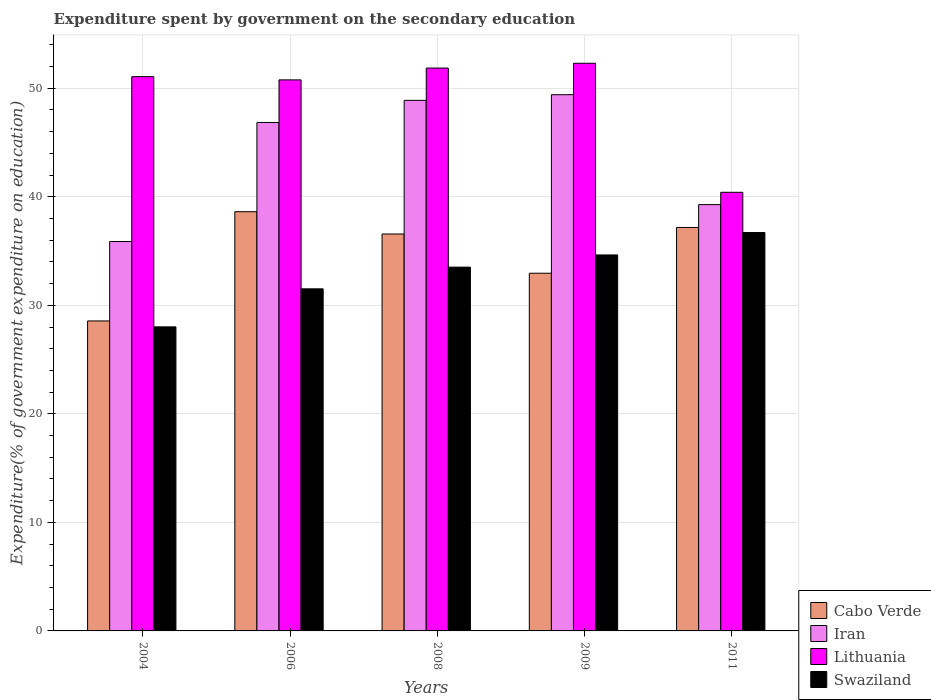How many groups of bars are there?
Give a very brief answer. 5. Are the number of bars per tick equal to the number of legend labels?
Provide a succinct answer. Yes. How many bars are there on the 3rd tick from the left?
Your answer should be compact. 4. What is the expenditure spent by government on the secondary education in Swaziland in 2004?
Provide a short and direct response. 28.02. Across all years, what is the maximum expenditure spent by government on the secondary education in Cabo Verde?
Provide a short and direct response. 38.63. Across all years, what is the minimum expenditure spent by government on the secondary education in Lithuania?
Ensure brevity in your answer.  40.42. In which year was the expenditure spent by government on the secondary education in Swaziland maximum?
Give a very brief answer. 2011. In which year was the expenditure spent by government on the secondary education in Iran minimum?
Offer a very short reply. 2004. What is the total expenditure spent by government on the secondary education in Cabo Verde in the graph?
Offer a very short reply. 173.89. What is the difference between the expenditure spent by government on the secondary education in Lithuania in 2008 and that in 2011?
Offer a terse response. 11.45. What is the difference between the expenditure spent by government on the secondary education in Iran in 2011 and the expenditure spent by government on the secondary education in Cabo Verde in 2009?
Your answer should be compact. 6.32. What is the average expenditure spent by government on the secondary education in Lithuania per year?
Keep it short and to the point. 49.29. In the year 2011, what is the difference between the expenditure spent by government on the secondary education in Swaziland and expenditure spent by government on the secondary education in Iran?
Offer a terse response. -2.57. What is the ratio of the expenditure spent by government on the secondary education in Swaziland in 2006 to that in 2011?
Provide a succinct answer. 0.86. What is the difference between the highest and the second highest expenditure spent by government on the secondary education in Cabo Verde?
Offer a terse response. 1.45. What is the difference between the highest and the lowest expenditure spent by government on the secondary education in Iran?
Your answer should be very brief. 13.53. In how many years, is the expenditure spent by government on the secondary education in Swaziland greater than the average expenditure spent by government on the secondary education in Swaziland taken over all years?
Make the answer very short. 3. Is it the case that in every year, the sum of the expenditure spent by government on the secondary education in Lithuania and expenditure spent by government on the secondary education in Cabo Verde is greater than the sum of expenditure spent by government on the secondary education in Iran and expenditure spent by government on the secondary education in Swaziland?
Give a very brief answer. No. What does the 2nd bar from the left in 2009 represents?
Keep it short and to the point. Iran. What does the 1st bar from the right in 2004 represents?
Provide a short and direct response. Swaziland. Is it the case that in every year, the sum of the expenditure spent by government on the secondary education in Cabo Verde and expenditure spent by government on the secondary education in Lithuania is greater than the expenditure spent by government on the secondary education in Iran?
Offer a very short reply. Yes. Are the values on the major ticks of Y-axis written in scientific E-notation?
Keep it short and to the point. No. Does the graph contain any zero values?
Give a very brief answer. No. Does the graph contain grids?
Your answer should be compact. Yes. Where does the legend appear in the graph?
Offer a terse response. Bottom right. What is the title of the graph?
Give a very brief answer. Expenditure spent by government on the secondary education. What is the label or title of the X-axis?
Provide a succinct answer. Years. What is the label or title of the Y-axis?
Offer a terse response. Expenditure(% of government expenditure on education). What is the Expenditure(% of government expenditure on education) in Cabo Verde in 2004?
Your answer should be compact. 28.56. What is the Expenditure(% of government expenditure on education) of Iran in 2004?
Ensure brevity in your answer.  35.88. What is the Expenditure(% of government expenditure on education) of Lithuania in 2004?
Provide a short and direct response. 51.07. What is the Expenditure(% of government expenditure on education) of Swaziland in 2004?
Provide a succinct answer. 28.02. What is the Expenditure(% of government expenditure on education) of Cabo Verde in 2006?
Offer a very short reply. 38.63. What is the Expenditure(% of government expenditure on education) of Iran in 2006?
Offer a very short reply. 46.85. What is the Expenditure(% of government expenditure on education) in Lithuania in 2006?
Offer a very short reply. 50.77. What is the Expenditure(% of government expenditure on education) in Swaziland in 2006?
Give a very brief answer. 31.52. What is the Expenditure(% of government expenditure on education) of Cabo Verde in 2008?
Provide a succinct answer. 36.57. What is the Expenditure(% of government expenditure on education) in Iran in 2008?
Ensure brevity in your answer.  48.89. What is the Expenditure(% of government expenditure on education) in Lithuania in 2008?
Your response must be concise. 51.86. What is the Expenditure(% of government expenditure on education) in Swaziland in 2008?
Offer a very short reply. 33.52. What is the Expenditure(% of government expenditure on education) of Cabo Verde in 2009?
Offer a terse response. 32.96. What is the Expenditure(% of government expenditure on education) in Iran in 2009?
Offer a terse response. 49.41. What is the Expenditure(% of government expenditure on education) of Lithuania in 2009?
Make the answer very short. 52.3. What is the Expenditure(% of government expenditure on education) in Swaziland in 2009?
Offer a very short reply. 34.64. What is the Expenditure(% of government expenditure on education) of Cabo Verde in 2011?
Provide a succinct answer. 37.17. What is the Expenditure(% of government expenditure on education) in Iran in 2011?
Your answer should be very brief. 39.28. What is the Expenditure(% of government expenditure on education) in Lithuania in 2011?
Your response must be concise. 40.42. What is the Expenditure(% of government expenditure on education) in Swaziland in 2011?
Keep it short and to the point. 36.71. Across all years, what is the maximum Expenditure(% of government expenditure on education) of Cabo Verde?
Provide a short and direct response. 38.63. Across all years, what is the maximum Expenditure(% of government expenditure on education) of Iran?
Give a very brief answer. 49.41. Across all years, what is the maximum Expenditure(% of government expenditure on education) of Lithuania?
Your response must be concise. 52.3. Across all years, what is the maximum Expenditure(% of government expenditure on education) of Swaziland?
Offer a terse response. 36.71. Across all years, what is the minimum Expenditure(% of government expenditure on education) in Cabo Verde?
Your answer should be very brief. 28.56. Across all years, what is the minimum Expenditure(% of government expenditure on education) in Iran?
Your answer should be compact. 35.88. Across all years, what is the minimum Expenditure(% of government expenditure on education) in Lithuania?
Keep it short and to the point. 40.42. Across all years, what is the minimum Expenditure(% of government expenditure on education) of Swaziland?
Offer a very short reply. 28.02. What is the total Expenditure(% of government expenditure on education) of Cabo Verde in the graph?
Offer a very short reply. 173.89. What is the total Expenditure(% of government expenditure on education) in Iran in the graph?
Ensure brevity in your answer.  220.3. What is the total Expenditure(% of government expenditure on education) in Lithuania in the graph?
Offer a very short reply. 246.43. What is the total Expenditure(% of government expenditure on education) in Swaziland in the graph?
Provide a succinct answer. 164.4. What is the difference between the Expenditure(% of government expenditure on education) in Cabo Verde in 2004 and that in 2006?
Give a very brief answer. -10.06. What is the difference between the Expenditure(% of government expenditure on education) in Iran in 2004 and that in 2006?
Offer a terse response. -10.97. What is the difference between the Expenditure(% of government expenditure on education) of Lithuania in 2004 and that in 2006?
Offer a terse response. 0.3. What is the difference between the Expenditure(% of government expenditure on education) in Swaziland in 2004 and that in 2006?
Make the answer very short. -3.5. What is the difference between the Expenditure(% of government expenditure on education) of Cabo Verde in 2004 and that in 2008?
Your answer should be very brief. -8.01. What is the difference between the Expenditure(% of government expenditure on education) of Iran in 2004 and that in 2008?
Offer a terse response. -13.01. What is the difference between the Expenditure(% of government expenditure on education) in Lithuania in 2004 and that in 2008?
Your answer should be compact. -0.79. What is the difference between the Expenditure(% of government expenditure on education) in Swaziland in 2004 and that in 2008?
Offer a very short reply. -5.5. What is the difference between the Expenditure(% of government expenditure on education) in Cabo Verde in 2004 and that in 2009?
Make the answer very short. -4.4. What is the difference between the Expenditure(% of government expenditure on education) of Iran in 2004 and that in 2009?
Give a very brief answer. -13.53. What is the difference between the Expenditure(% of government expenditure on education) of Lithuania in 2004 and that in 2009?
Offer a terse response. -1.23. What is the difference between the Expenditure(% of government expenditure on education) in Swaziland in 2004 and that in 2009?
Give a very brief answer. -6.63. What is the difference between the Expenditure(% of government expenditure on education) of Cabo Verde in 2004 and that in 2011?
Your answer should be very brief. -8.61. What is the difference between the Expenditure(% of government expenditure on education) of Iran in 2004 and that in 2011?
Keep it short and to the point. -3.4. What is the difference between the Expenditure(% of government expenditure on education) of Lithuania in 2004 and that in 2011?
Your answer should be compact. 10.66. What is the difference between the Expenditure(% of government expenditure on education) of Swaziland in 2004 and that in 2011?
Offer a very short reply. -8.69. What is the difference between the Expenditure(% of government expenditure on education) in Cabo Verde in 2006 and that in 2008?
Give a very brief answer. 2.05. What is the difference between the Expenditure(% of government expenditure on education) of Iran in 2006 and that in 2008?
Make the answer very short. -2.04. What is the difference between the Expenditure(% of government expenditure on education) of Lithuania in 2006 and that in 2008?
Provide a short and direct response. -1.09. What is the difference between the Expenditure(% of government expenditure on education) in Swaziland in 2006 and that in 2008?
Ensure brevity in your answer.  -2. What is the difference between the Expenditure(% of government expenditure on education) in Cabo Verde in 2006 and that in 2009?
Your answer should be compact. 5.67. What is the difference between the Expenditure(% of government expenditure on education) of Iran in 2006 and that in 2009?
Keep it short and to the point. -2.56. What is the difference between the Expenditure(% of government expenditure on education) in Lithuania in 2006 and that in 2009?
Your response must be concise. -1.53. What is the difference between the Expenditure(% of government expenditure on education) in Swaziland in 2006 and that in 2009?
Your response must be concise. -3.12. What is the difference between the Expenditure(% of government expenditure on education) in Cabo Verde in 2006 and that in 2011?
Your answer should be compact. 1.45. What is the difference between the Expenditure(% of government expenditure on education) in Iran in 2006 and that in 2011?
Give a very brief answer. 7.57. What is the difference between the Expenditure(% of government expenditure on education) of Lithuania in 2006 and that in 2011?
Make the answer very short. 10.36. What is the difference between the Expenditure(% of government expenditure on education) in Swaziland in 2006 and that in 2011?
Keep it short and to the point. -5.19. What is the difference between the Expenditure(% of government expenditure on education) in Cabo Verde in 2008 and that in 2009?
Give a very brief answer. 3.62. What is the difference between the Expenditure(% of government expenditure on education) of Iran in 2008 and that in 2009?
Ensure brevity in your answer.  -0.52. What is the difference between the Expenditure(% of government expenditure on education) of Lithuania in 2008 and that in 2009?
Offer a terse response. -0.44. What is the difference between the Expenditure(% of government expenditure on education) in Swaziland in 2008 and that in 2009?
Make the answer very short. -1.12. What is the difference between the Expenditure(% of government expenditure on education) in Cabo Verde in 2008 and that in 2011?
Keep it short and to the point. -0.6. What is the difference between the Expenditure(% of government expenditure on education) of Iran in 2008 and that in 2011?
Give a very brief answer. 9.61. What is the difference between the Expenditure(% of government expenditure on education) in Lithuania in 2008 and that in 2011?
Your answer should be compact. 11.45. What is the difference between the Expenditure(% of government expenditure on education) in Swaziland in 2008 and that in 2011?
Your answer should be compact. -3.19. What is the difference between the Expenditure(% of government expenditure on education) in Cabo Verde in 2009 and that in 2011?
Provide a succinct answer. -4.22. What is the difference between the Expenditure(% of government expenditure on education) of Iran in 2009 and that in 2011?
Keep it short and to the point. 10.13. What is the difference between the Expenditure(% of government expenditure on education) of Lithuania in 2009 and that in 2011?
Provide a short and direct response. 11.89. What is the difference between the Expenditure(% of government expenditure on education) in Swaziland in 2009 and that in 2011?
Ensure brevity in your answer.  -2.06. What is the difference between the Expenditure(% of government expenditure on education) of Cabo Verde in 2004 and the Expenditure(% of government expenditure on education) of Iran in 2006?
Offer a terse response. -18.29. What is the difference between the Expenditure(% of government expenditure on education) in Cabo Verde in 2004 and the Expenditure(% of government expenditure on education) in Lithuania in 2006?
Make the answer very short. -22.21. What is the difference between the Expenditure(% of government expenditure on education) in Cabo Verde in 2004 and the Expenditure(% of government expenditure on education) in Swaziland in 2006?
Your response must be concise. -2.96. What is the difference between the Expenditure(% of government expenditure on education) in Iran in 2004 and the Expenditure(% of government expenditure on education) in Lithuania in 2006?
Give a very brief answer. -14.89. What is the difference between the Expenditure(% of government expenditure on education) in Iran in 2004 and the Expenditure(% of government expenditure on education) in Swaziland in 2006?
Provide a short and direct response. 4.36. What is the difference between the Expenditure(% of government expenditure on education) of Lithuania in 2004 and the Expenditure(% of government expenditure on education) of Swaziland in 2006?
Give a very brief answer. 19.55. What is the difference between the Expenditure(% of government expenditure on education) of Cabo Verde in 2004 and the Expenditure(% of government expenditure on education) of Iran in 2008?
Ensure brevity in your answer.  -20.32. What is the difference between the Expenditure(% of government expenditure on education) in Cabo Verde in 2004 and the Expenditure(% of government expenditure on education) in Lithuania in 2008?
Give a very brief answer. -23.3. What is the difference between the Expenditure(% of government expenditure on education) in Cabo Verde in 2004 and the Expenditure(% of government expenditure on education) in Swaziland in 2008?
Keep it short and to the point. -4.96. What is the difference between the Expenditure(% of government expenditure on education) of Iran in 2004 and the Expenditure(% of government expenditure on education) of Lithuania in 2008?
Your answer should be very brief. -15.98. What is the difference between the Expenditure(% of government expenditure on education) of Iran in 2004 and the Expenditure(% of government expenditure on education) of Swaziland in 2008?
Make the answer very short. 2.36. What is the difference between the Expenditure(% of government expenditure on education) of Lithuania in 2004 and the Expenditure(% of government expenditure on education) of Swaziland in 2008?
Give a very brief answer. 17.55. What is the difference between the Expenditure(% of government expenditure on education) in Cabo Verde in 2004 and the Expenditure(% of government expenditure on education) in Iran in 2009?
Your response must be concise. -20.85. What is the difference between the Expenditure(% of government expenditure on education) of Cabo Verde in 2004 and the Expenditure(% of government expenditure on education) of Lithuania in 2009?
Offer a terse response. -23.74. What is the difference between the Expenditure(% of government expenditure on education) of Cabo Verde in 2004 and the Expenditure(% of government expenditure on education) of Swaziland in 2009?
Your answer should be compact. -6.08. What is the difference between the Expenditure(% of government expenditure on education) in Iran in 2004 and the Expenditure(% of government expenditure on education) in Lithuania in 2009?
Offer a very short reply. -16.42. What is the difference between the Expenditure(% of government expenditure on education) in Iran in 2004 and the Expenditure(% of government expenditure on education) in Swaziland in 2009?
Your response must be concise. 1.24. What is the difference between the Expenditure(% of government expenditure on education) of Lithuania in 2004 and the Expenditure(% of government expenditure on education) of Swaziland in 2009?
Provide a succinct answer. 16.43. What is the difference between the Expenditure(% of government expenditure on education) of Cabo Verde in 2004 and the Expenditure(% of government expenditure on education) of Iran in 2011?
Ensure brevity in your answer.  -10.72. What is the difference between the Expenditure(% of government expenditure on education) of Cabo Verde in 2004 and the Expenditure(% of government expenditure on education) of Lithuania in 2011?
Keep it short and to the point. -11.85. What is the difference between the Expenditure(% of government expenditure on education) in Cabo Verde in 2004 and the Expenditure(% of government expenditure on education) in Swaziland in 2011?
Your answer should be very brief. -8.14. What is the difference between the Expenditure(% of government expenditure on education) in Iran in 2004 and the Expenditure(% of government expenditure on education) in Lithuania in 2011?
Provide a short and direct response. -4.53. What is the difference between the Expenditure(% of government expenditure on education) of Iran in 2004 and the Expenditure(% of government expenditure on education) of Swaziland in 2011?
Provide a succinct answer. -0.82. What is the difference between the Expenditure(% of government expenditure on education) in Lithuania in 2004 and the Expenditure(% of government expenditure on education) in Swaziland in 2011?
Your response must be concise. 14.37. What is the difference between the Expenditure(% of government expenditure on education) in Cabo Verde in 2006 and the Expenditure(% of government expenditure on education) in Iran in 2008?
Keep it short and to the point. -10.26. What is the difference between the Expenditure(% of government expenditure on education) of Cabo Verde in 2006 and the Expenditure(% of government expenditure on education) of Lithuania in 2008?
Your response must be concise. -13.24. What is the difference between the Expenditure(% of government expenditure on education) of Cabo Verde in 2006 and the Expenditure(% of government expenditure on education) of Swaziland in 2008?
Your response must be concise. 5.11. What is the difference between the Expenditure(% of government expenditure on education) in Iran in 2006 and the Expenditure(% of government expenditure on education) in Lithuania in 2008?
Provide a short and direct response. -5.01. What is the difference between the Expenditure(% of government expenditure on education) in Iran in 2006 and the Expenditure(% of government expenditure on education) in Swaziland in 2008?
Provide a succinct answer. 13.33. What is the difference between the Expenditure(% of government expenditure on education) in Lithuania in 2006 and the Expenditure(% of government expenditure on education) in Swaziland in 2008?
Keep it short and to the point. 17.25. What is the difference between the Expenditure(% of government expenditure on education) of Cabo Verde in 2006 and the Expenditure(% of government expenditure on education) of Iran in 2009?
Keep it short and to the point. -10.78. What is the difference between the Expenditure(% of government expenditure on education) in Cabo Verde in 2006 and the Expenditure(% of government expenditure on education) in Lithuania in 2009?
Your response must be concise. -13.68. What is the difference between the Expenditure(% of government expenditure on education) in Cabo Verde in 2006 and the Expenditure(% of government expenditure on education) in Swaziland in 2009?
Offer a very short reply. 3.98. What is the difference between the Expenditure(% of government expenditure on education) of Iran in 2006 and the Expenditure(% of government expenditure on education) of Lithuania in 2009?
Make the answer very short. -5.46. What is the difference between the Expenditure(% of government expenditure on education) in Iran in 2006 and the Expenditure(% of government expenditure on education) in Swaziland in 2009?
Your answer should be very brief. 12.21. What is the difference between the Expenditure(% of government expenditure on education) in Lithuania in 2006 and the Expenditure(% of government expenditure on education) in Swaziland in 2009?
Make the answer very short. 16.13. What is the difference between the Expenditure(% of government expenditure on education) of Cabo Verde in 2006 and the Expenditure(% of government expenditure on education) of Iran in 2011?
Ensure brevity in your answer.  -0.65. What is the difference between the Expenditure(% of government expenditure on education) in Cabo Verde in 2006 and the Expenditure(% of government expenditure on education) in Lithuania in 2011?
Your response must be concise. -1.79. What is the difference between the Expenditure(% of government expenditure on education) in Cabo Verde in 2006 and the Expenditure(% of government expenditure on education) in Swaziland in 2011?
Ensure brevity in your answer.  1.92. What is the difference between the Expenditure(% of government expenditure on education) of Iran in 2006 and the Expenditure(% of government expenditure on education) of Lithuania in 2011?
Provide a succinct answer. 6.43. What is the difference between the Expenditure(% of government expenditure on education) of Iran in 2006 and the Expenditure(% of government expenditure on education) of Swaziland in 2011?
Your answer should be very brief. 10.14. What is the difference between the Expenditure(% of government expenditure on education) in Lithuania in 2006 and the Expenditure(% of government expenditure on education) in Swaziland in 2011?
Provide a short and direct response. 14.07. What is the difference between the Expenditure(% of government expenditure on education) in Cabo Verde in 2008 and the Expenditure(% of government expenditure on education) in Iran in 2009?
Your response must be concise. -12.83. What is the difference between the Expenditure(% of government expenditure on education) of Cabo Verde in 2008 and the Expenditure(% of government expenditure on education) of Lithuania in 2009?
Make the answer very short. -15.73. What is the difference between the Expenditure(% of government expenditure on education) of Cabo Verde in 2008 and the Expenditure(% of government expenditure on education) of Swaziland in 2009?
Keep it short and to the point. 1.93. What is the difference between the Expenditure(% of government expenditure on education) of Iran in 2008 and the Expenditure(% of government expenditure on education) of Lithuania in 2009?
Your answer should be compact. -3.42. What is the difference between the Expenditure(% of government expenditure on education) in Iran in 2008 and the Expenditure(% of government expenditure on education) in Swaziland in 2009?
Your answer should be compact. 14.24. What is the difference between the Expenditure(% of government expenditure on education) in Lithuania in 2008 and the Expenditure(% of government expenditure on education) in Swaziland in 2009?
Provide a short and direct response. 17.22. What is the difference between the Expenditure(% of government expenditure on education) in Cabo Verde in 2008 and the Expenditure(% of government expenditure on education) in Iran in 2011?
Ensure brevity in your answer.  -2.71. What is the difference between the Expenditure(% of government expenditure on education) of Cabo Verde in 2008 and the Expenditure(% of government expenditure on education) of Lithuania in 2011?
Give a very brief answer. -3.84. What is the difference between the Expenditure(% of government expenditure on education) of Cabo Verde in 2008 and the Expenditure(% of government expenditure on education) of Swaziland in 2011?
Ensure brevity in your answer.  -0.13. What is the difference between the Expenditure(% of government expenditure on education) in Iran in 2008 and the Expenditure(% of government expenditure on education) in Lithuania in 2011?
Make the answer very short. 8.47. What is the difference between the Expenditure(% of government expenditure on education) of Iran in 2008 and the Expenditure(% of government expenditure on education) of Swaziland in 2011?
Offer a very short reply. 12.18. What is the difference between the Expenditure(% of government expenditure on education) of Lithuania in 2008 and the Expenditure(% of government expenditure on education) of Swaziland in 2011?
Ensure brevity in your answer.  15.16. What is the difference between the Expenditure(% of government expenditure on education) in Cabo Verde in 2009 and the Expenditure(% of government expenditure on education) in Iran in 2011?
Provide a succinct answer. -6.32. What is the difference between the Expenditure(% of government expenditure on education) of Cabo Verde in 2009 and the Expenditure(% of government expenditure on education) of Lithuania in 2011?
Ensure brevity in your answer.  -7.46. What is the difference between the Expenditure(% of government expenditure on education) in Cabo Verde in 2009 and the Expenditure(% of government expenditure on education) in Swaziland in 2011?
Keep it short and to the point. -3.75. What is the difference between the Expenditure(% of government expenditure on education) of Iran in 2009 and the Expenditure(% of government expenditure on education) of Lithuania in 2011?
Make the answer very short. 8.99. What is the difference between the Expenditure(% of government expenditure on education) of Iran in 2009 and the Expenditure(% of government expenditure on education) of Swaziland in 2011?
Give a very brief answer. 12.7. What is the difference between the Expenditure(% of government expenditure on education) of Lithuania in 2009 and the Expenditure(% of government expenditure on education) of Swaziland in 2011?
Provide a succinct answer. 15.6. What is the average Expenditure(% of government expenditure on education) in Cabo Verde per year?
Keep it short and to the point. 34.78. What is the average Expenditure(% of government expenditure on education) in Iran per year?
Ensure brevity in your answer.  44.06. What is the average Expenditure(% of government expenditure on education) in Lithuania per year?
Your answer should be very brief. 49.29. What is the average Expenditure(% of government expenditure on education) of Swaziland per year?
Keep it short and to the point. 32.88. In the year 2004, what is the difference between the Expenditure(% of government expenditure on education) in Cabo Verde and Expenditure(% of government expenditure on education) in Iran?
Make the answer very short. -7.32. In the year 2004, what is the difference between the Expenditure(% of government expenditure on education) in Cabo Verde and Expenditure(% of government expenditure on education) in Lithuania?
Ensure brevity in your answer.  -22.51. In the year 2004, what is the difference between the Expenditure(% of government expenditure on education) in Cabo Verde and Expenditure(% of government expenditure on education) in Swaziland?
Keep it short and to the point. 0.55. In the year 2004, what is the difference between the Expenditure(% of government expenditure on education) in Iran and Expenditure(% of government expenditure on education) in Lithuania?
Your response must be concise. -15.19. In the year 2004, what is the difference between the Expenditure(% of government expenditure on education) of Iran and Expenditure(% of government expenditure on education) of Swaziland?
Make the answer very short. 7.87. In the year 2004, what is the difference between the Expenditure(% of government expenditure on education) in Lithuania and Expenditure(% of government expenditure on education) in Swaziland?
Offer a very short reply. 23.06. In the year 2006, what is the difference between the Expenditure(% of government expenditure on education) of Cabo Verde and Expenditure(% of government expenditure on education) of Iran?
Your answer should be compact. -8.22. In the year 2006, what is the difference between the Expenditure(% of government expenditure on education) in Cabo Verde and Expenditure(% of government expenditure on education) in Lithuania?
Your answer should be compact. -12.15. In the year 2006, what is the difference between the Expenditure(% of government expenditure on education) in Cabo Verde and Expenditure(% of government expenditure on education) in Swaziland?
Your response must be concise. 7.11. In the year 2006, what is the difference between the Expenditure(% of government expenditure on education) of Iran and Expenditure(% of government expenditure on education) of Lithuania?
Your response must be concise. -3.92. In the year 2006, what is the difference between the Expenditure(% of government expenditure on education) in Iran and Expenditure(% of government expenditure on education) in Swaziland?
Offer a terse response. 15.33. In the year 2006, what is the difference between the Expenditure(% of government expenditure on education) of Lithuania and Expenditure(% of government expenditure on education) of Swaziland?
Offer a very short reply. 19.25. In the year 2008, what is the difference between the Expenditure(% of government expenditure on education) of Cabo Verde and Expenditure(% of government expenditure on education) of Iran?
Make the answer very short. -12.31. In the year 2008, what is the difference between the Expenditure(% of government expenditure on education) of Cabo Verde and Expenditure(% of government expenditure on education) of Lithuania?
Give a very brief answer. -15.29. In the year 2008, what is the difference between the Expenditure(% of government expenditure on education) of Cabo Verde and Expenditure(% of government expenditure on education) of Swaziland?
Ensure brevity in your answer.  3.05. In the year 2008, what is the difference between the Expenditure(% of government expenditure on education) in Iran and Expenditure(% of government expenditure on education) in Lithuania?
Your answer should be very brief. -2.98. In the year 2008, what is the difference between the Expenditure(% of government expenditure on education) in Iran and Expenditure(% of government expenditure on education) in Swaziland?
Your answer should be compact. 15.37. In the year 2008, what is the difference between the Expenditure(% of government expenditure on education) in Lithuania and Expenditure(% of government expenditure on education) in Swaziland?
Offer a very short reply. 18.34. In the year 2009, what is the difference between the Expenditure(% of government expenditure on education) of Cabo Verde and Expenditure(% of government expenditure on education) of Iran?
Provide a succinct answer. -16.45. In the year 2009, what is the difference between the Expenditure(% of government expenditure on education) in Cabo Verde and Expenditure(% of government expenditure on education) in Lithuania?
Your answer should be very brief. -19.35. In the year 2009, what is the difference between the Expenditure(% of government expenditure on education) in Cabo Verde and Expenditure(% of government expenditure on education) in Swaziland?
Provide a succinct answer. -1.68. In the year 2009, what is the difference between the Expenditure(% of government expenditure on education) of Iran and Expenditure(% of government expenditure on education) of Lithuania?
Provide a succinct answer. -2.9. In the year 2009, what is the difference between the Expenditure(% of government expenditure on education) in Iran and Expenditure(% of government expenditure on education) in Swaziland?
Provide a succinct answer. 14.77. In the year 2009, what is the difference between the Expenditure(% of government expenditure on education) of Lithuania and Expenditure(% of government expenditure on education) of Swaziland?
Your answer should be very brief. 17.66. In the year 2011, what is the difference between the Expenditure(% of government expenditure on education) in Cabo Verde and Expenditure(% of government expenditure on education) in Iran?
Offer a very short reply. -2.1. In the year 2011, what is the difference between the Expenditure(% of government expenditure on education) of Cabo Verde and Expenditure(% of government expenditure on education) of Lithuania?
Ensure brevity in your answer.  -3.24. In the year 2011, what is the difference between the Expenditure(% of government expenditure on education) of Cabo Verde and Expenditure(% of government expenditure on education) of Swaziland?
Provide a short and direct response. 0.47. In the year 2011, what is the difference between the Expenditure(% of government expenditure on education) in Iran and Expenditure(% of government expenditure on education) in Lithuania?
Offer a terse response. -1.14. In the year 2011, what is the difference between the Expenditure(% of government expenditure on education) in Iran and Expenditure(% of government expenditure on education) in Swaziland?
Provide a short and direct response. 2.57. In the year 2011, what is the difference between the Expenditure(% of government expenditure on education) in Lithuania and Expenditure(% of government expenditure on education) in Swaziland?
Give a very brief answer. 3.71. What is the ratio of the Expenditure(% of government expenditure on education) of Cabo Verde in 2004 to that in 2006?
Give a very brief answer. 0.74. What is the ratio of the Expenditure(% of government expenditure on education) of Iran in 2004 to that in 2006?
Offer a very short reply. 0.77. What is the ratio of the Expenditure(% of government expenditure on education) of Lithuania in 2004 to that in 2006?
Make the answer very short. 1.01. What is the ratio of the Expenditure(% of government expenditure on education) of Swaziland in 2004 to that in 2006?
Offer a terse response. 0.89. What is the ratio of the Expenditure(% of government expenditure on education) of Cabo Verde in 2004 to that in 2008?
Your response must be concise. 0.78. What is the ratio of the Expenditure(% of government expenditure on education) in Iran in 2004 to that in 2008?
Provide a short and direct response. 0.73. What is the ratio of the Expenditure(% of government expenditure on education) of Lithuania in 2004 to that in 2008?
Your answer should be very brief. 0.98. What is the ratio of the Expenditure(% of government expenditure on education) of Swaziland in 2004 to that in 2008?
Provide a short and direct response. 0.84. What is the ratio of the Expenditure(% of government expenditure on education) in Cabo Verde in 2004 to that in 2009?
Make the answer very short. 0.87. What is the ratio of the Expenditure(% of government expenditure on education) of Iran in 2004 to that in 2009?
Your answer should be very brief. 0.73. What is the ratio of the Expenditure(% of government expenditure on education) of Lithuania in 2004 to that in 2009?
Keep it short and to the point. 0.98. What is the ratio of the Expenditure(% of government expenditure on education) in Swaziland in 2004 to that in 2009?
Keep it short and to the point. 0.81. What is the ratio of the Expenditure(% of government expenditure on education) in Cabo Verde in 2004 to that in 2011?
Make the answer very short. 0.77. What is the ratio of the Expenditure(% of government expenditure on education) of Iran in 2004 to that in 2011?
Your response must be concise. 0.91. What is the ratio of the Expenditure(% of government expenditure on education) in Lithuania in 2004 to that in 2011?
Keep it short and to the point. 1.26. What is the ratio of the Expenditure(% of government expenditure on education) in Swaziland in 2004 to that in 2011?
Make the answer very short. 0.76. What is the ratio of the Expenditure(% of government expenditure on education) in Cabo Verde in 2006 to that in 2008?
Your response must be concise. 1.06. What is the ratio of the Expenditure(% of government expenditure on education) in Lithuania in 2006 to that in 2008?
Give a very brief answer. 0.98. What is the ratio of the Expenditure(% of government expenditure on education) in Swaziland in 2006 to that in 2008?
Provide a succinct answer. 0.94. What is the ratio of the Expenditure(% of government expenditure on education) of Cabo Verde in 2006 to that in 2009?
Your answer should be compact. 1.17. What is the ratio of the Expenditure(% of government expenditure on education) in Iran in 2006 to that in 2009?
Offer a terse response. 0.95. What is the ratio of the Expenditure(% of government expenditure on education) of Lithuania in 2006 to that in 2009?
Ensure brevity in your answer.  0.97. What is the ratio of the Expenditure(% of government expenditure on education) of Swaziland in 2006 to that in 2009?
Offer a very short reply. 0.91. What is the ratio of the Expenditure(% of government expenditure on education) of Cabo Verde in 2006 to that in 2011?
Give a very brief answer. 1.04. What is the ratio of the Expenditure(% of government expenditure on education) of Iran in 2006 to that in 2011?
Your response must be concise. 1.19. What is the ratio of the Expenditure(% of government expenditure on education) in Lithuania in 2006 to that in 2011?
Your answer should be compact. 1.26. What is the ratio of the Expenditure(% of government expenditure on education) in Swaziland in 2006 to that in 2011?
Offer a terse response. 0.86. What is the ratio of the Expenditure(% of government expenditure on education) of Cabo Verde in 2008 to that in 2009?
Your answer should be compact. 1.11. What is the ratio of the Expenditure(% of government expenditure on education) of Iran in 2008 to that in 2009?
Your response must be concise. 0.99. What is the ratio of the Expenditure(% of government expenditure on education) of Lithuania in 2008 to that in 2009?
Offer a terse response. 0.99. What is the ratio of the Expenditure(% of government expenditure on education) in Swaziland in 2008 to that in 2009?
Your answer should be compact. 0.97. What is the ratio of the Expenditure(% of government expenditure on education) of Cabo Verde in 2008 to that in 2011?
Ensure brevity in your answer.  0.98. What is the ratio of the Expenditure(% of government expenditure on education) of Iran in 2008 to that in 2011?
Keep it short and to the point. 1.24. What is the ratio of the Expenditure(% of government expenditure on education) in Lithuania in 2008 to that in 2011?
Give a very brief answer. 1.28. What is the ratio of the Expenditure(% of government expenditure on education) in Swaziland in 2008 to that in 2011?
Offer a very short reply. 0.91. What is the ratio of the Expenditure(% of government expenditure on education) in Cabo Verde in 2009 to that in 2011?
Make the answer very short. 0.89. What is the ratio of the Expenditure(% of government expenditure on education) in Iran in 2009 to that in 2011?
Provide a short and direct response. 1.26. What is the ratio of the Expenditure(% of government expenditure on education) of Lithuania in 2009 to that in 2011?
Your answer should be compact. 1.29. What is the ratio of the Expenditure(% of government expenditure on education) of Swaziland in 2009 to that in 2011?
Provide a succinct answer. 0.94. What is the difference between the highest and the second highest Expenditure(% of government expenditure on education) in Cabo Verde?
Make the answer very short. 1.45. What is the difference between the highest and the second highest Expenditure(% of government expenditure on education) in Iran?
Provide a short and direct response. 0.52. What is the difference between the highest and the second highest Expenditure(% of government expenditure on education) in Lithuania?
Your answer should be compact. 0.44. What is the difference between the highest and the second highest Expenditure(% of government expenditure on education) in Swaziland?
Give a very brief answer. 2.06. What is the difference between the highest and the lowest Expenditure(% of government expenditure on education) in Cabo Verde?
Make the answer very short. 10.06. What is the difference between the highest and the lowest Expenditure(% of government expenditure on education) in Iran?
Your response must be concise. 13.53. What is the difference between the highest and the lowest Expenditure(% of government expenditure on education) in Lithuania?
Give a very brief answer. 11.89. What is the difference between the highest and the lowest Expenditure(% of government expenditure on education) of Swaziland?
Your answer should be very brief. 8.69. 